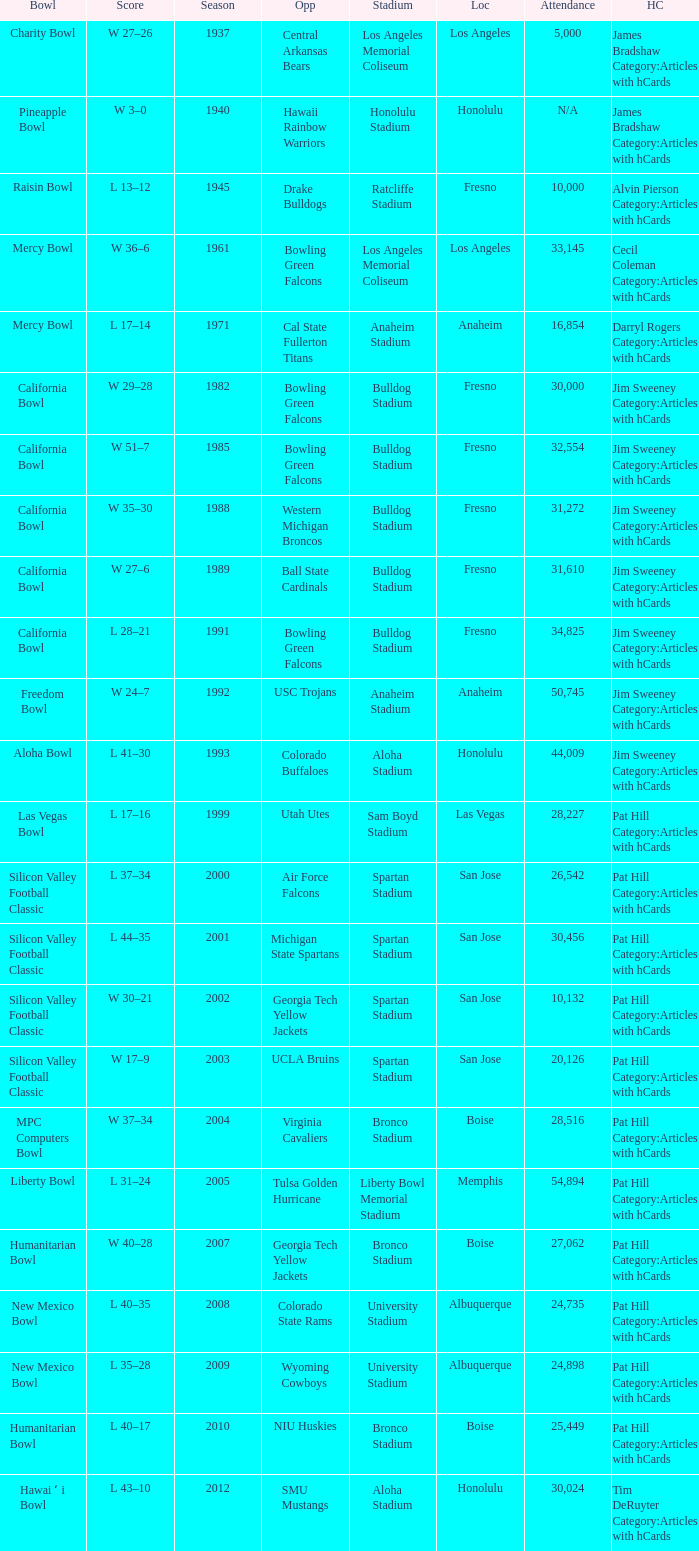What stadium had an opponent of Cal State Fullerton Titans? Anaheim Stadium. 